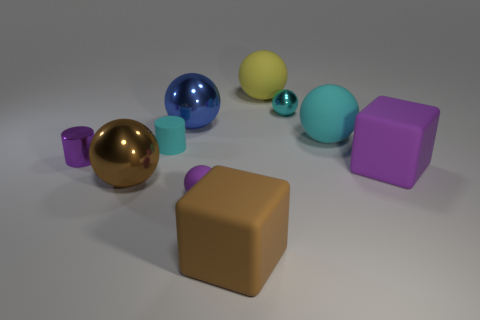Subtract all big brown metal balls. How many balls are left? 5 Subtract all cyan cylinders. How many cyan spheres are left? 2 Subtract 1 blocks. How many blocks are left? 1 Subtract all yellow balls. How many balls are left? 5 Subtract all blue balls. Subtract all brown cylinders. How many balls are left? 5 Subtract all large matte cubes. Subtract all large yellow things. How many objects are left? 7 Add 8 large cyan rubber spheres. How many large cyan rubber spheres are left? 9 Add 2 big brown shiny balls. How many big brown shiny balls exist? 3 Subtract 0 green balls. How many objects are left? 10 Subtract all cylinders. How many objects are left? 8 